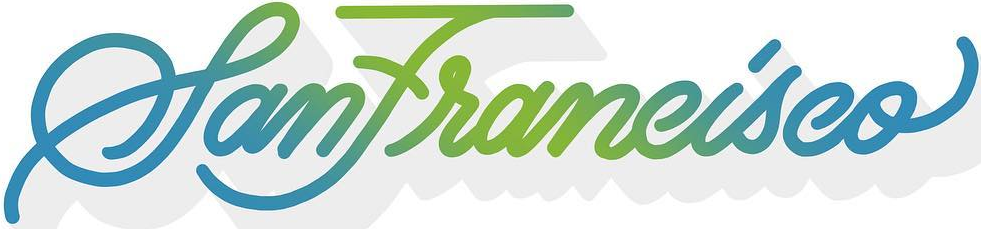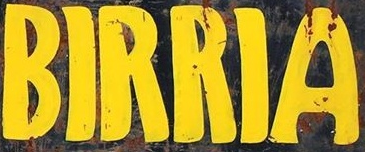What words are shown in these images in order, separated by a semicolon? SanFrancisco; BIRRIA 